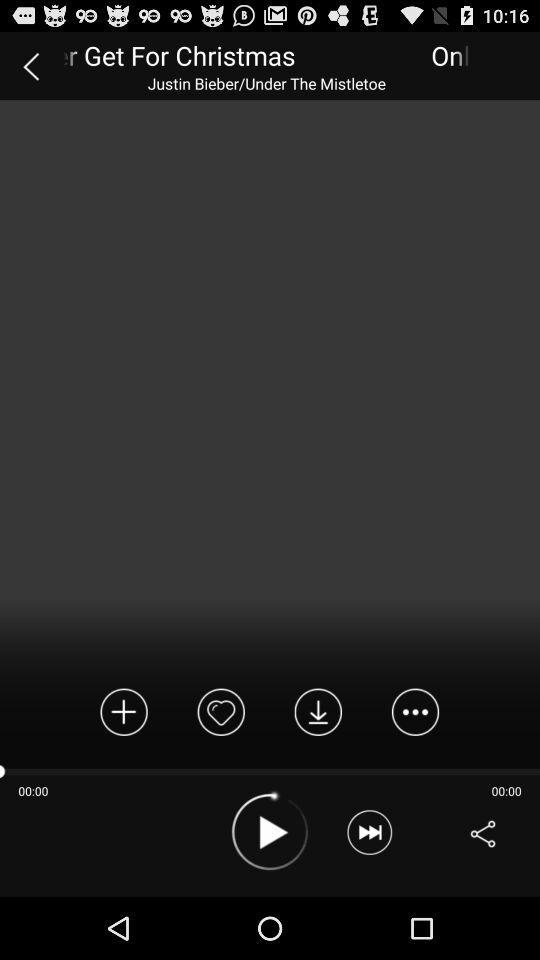Who is the artist of this song? The artist of this song is Justin Bieber. 